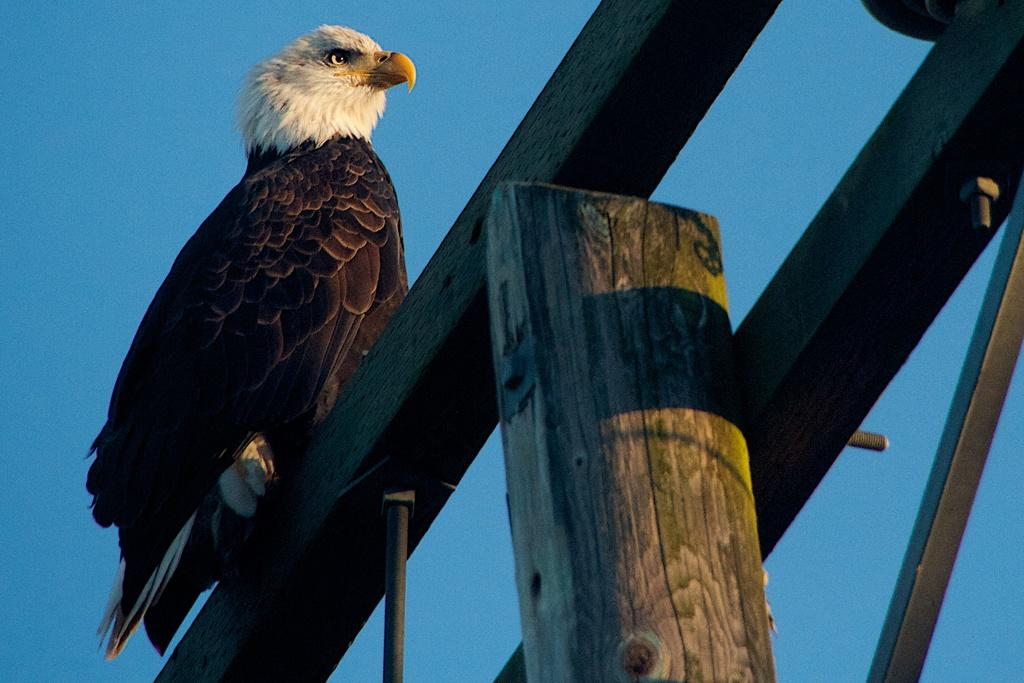What can be seen in the background of the image? There is a sky in the image. What objects are present in the foreground of the image? There are wooden sticks in the image. What is the animal doing on the wooden sticks? The animal is standing on the wooden sticks. What type of notebook is the animal using to write on the wooden sticks? There is no notebook present in the image, and the animal is not writing on the wooden sticks. 